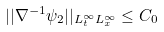<formula> <loc_0><loc_0><loc_500><loc_500>| | \nabla ^ { - 1 } \psi _ { 2 } | | _ { L _ { t } ^ { \infty } L _ { x } ^ { \infty } } \leq C _ { 0 }</formula> 